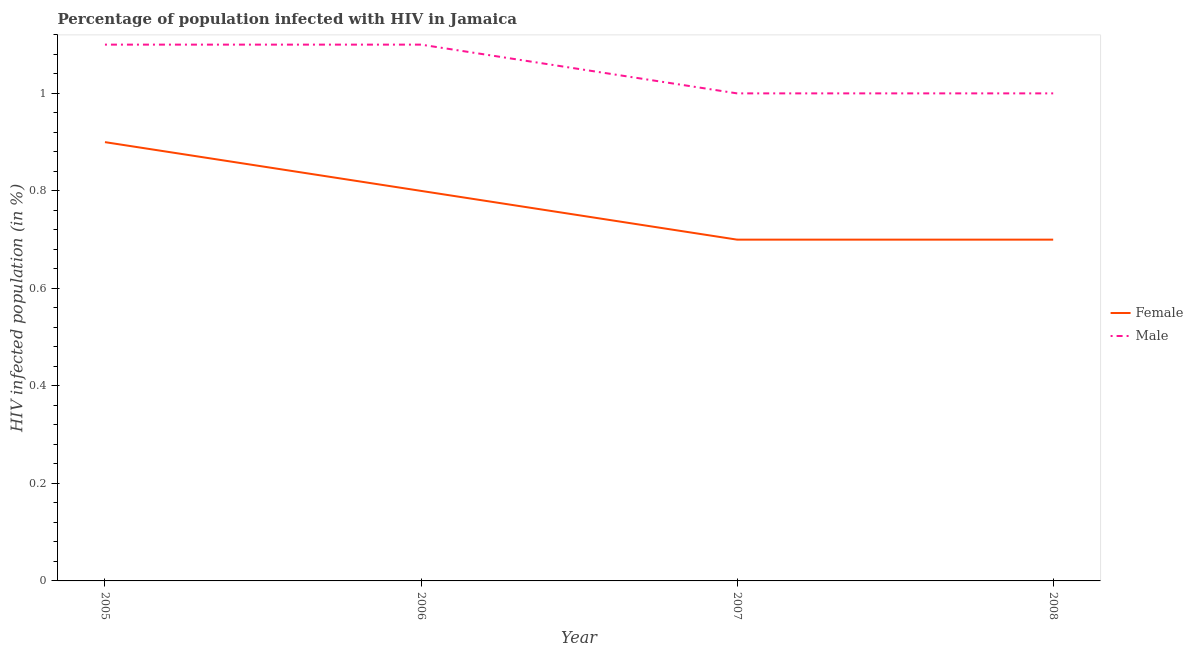How many different coloured lines are there?
Make the answer very short. 2. What is the total percentage of males who are infected with hiv in the graph?
Offer a very short reply. 4.2. What is the difference between the percentage of males who are infected with hiv in 2007 and the percentage of females who are infected with hiv in 2005?
Provide a succinct answer. 0.1. What is the average percentage of females who are infected with hiv per year?
Make the answer very short. 0.78. In the year 2006, what is the difference between the percentage of females who are infected with hiv and percentage of males who are infected with hiv?
Your answer should be compact. -0.3. In how many years, is the percentage of males who are infected with hiv greater than 0.48000000000000004 %?
Ensure brevity in your answer.  4. What is the ratio of the percentage of females who are infected with hiv in 2005 to that in 2006?
Provide a short and direct response. 1.12. Is the percentage of males who are infected with hiv in 2007 less than that in 2008?
Make the answer very short. No. Is the difference between the percentage of males who are infected with hiv in 2005 and 2006 greater than the difference between the percentage of females who are infected with hiv in 2005 and 2006?
Give a very brief answer. No. What is the difference between the highest and the second highest percentage of females who are infected with hiv?
Provide a succinct answer. 0.1. What is the difference between the highest and the lowest percentage of males who are infected with hiv?
Your answer should be very brief. 0.1. Is the percentage of females who are infected with hiv strictly greater than the percentage of males who are infected with hiv over the years?
Offer a terse response. No. How many lines are there?
Your response must be concise. 2. Are the values on the major ticks of Y-axis written in scientific E-notation?
Provide a succinct answer. No. Does the graph contain grids?
Provide a short and direct response. No. How are the legend labels stacked?
Ensure brevity in your answer.  Vertical. What is the title of the graph?
Ensure brevity in your answer.  Percentage of population infected with HIV in Jamaica. What is the label or title of the X-axis?
Offer a terse response. Year. What is the label or title of the Y-axis?
Your answer should be compact. HIV infected population (in %). What is the HIV infected population (in %) in Female in 2005?
Your answer should be very brief. 0.9. What is the HIV infected population (in %) of Male in 2005?
Your response must be concise. 1.1. What is the HIV infected population (in %) of Female in 2007?
Ensure brevity in your answer.  0.7. What is the HIV infected population (in %) in Female in 2008?
Ensure brevity in your answer.  0.7. Across all years, what is the maximum HIV infected population (in %) in Female?
Make the answer very short. 0.9. Across all years, what is the maximum HIV infected population (in %) of Male?
Give a very brief answer. 1.1. Across all years, what is the minimum HIV infected population (in %) of Female?
Keep it short and to the point. 0.7. Across all years, what is the minimum HIV infected population (in %) of Male?
Your response must be concise. 1. What is the difference between the HIV infected population (in %) of Female in 2005 and that in 2006?
Provide a succinct answer. 0.1. What is the difference between the HIV infected population (in %) in Male in 2005 and that in 2006?
Give a very brief answer. 0. What is the difference between the HIV infected population (in %) in Female in 2005 and that in 2007?
Keep it short and to the point. 0.2. What is the difference between the HIV infected population (in %) in Male in 2006 and that in 2007?
Provide a short and direct response. 0.1. What is the difference between the HIV infected population (in %) in Female in 2006 and that in 2008?
Offer a very short reply. 0.1. What is the difference between the HIV infected population (in %) of Male in 2006 and that in 2008?
Ensure brevity in your answer.  0.1. What is the difference between the HIV infected population (in %) of Female in 2005 and the HIV infected population (in %) of Male in 2006?
Provide a short and direct response. -0.2. What is the difference between the HIV infected population (in %) of Female in 2005 and the HIV infected population (in %) of Male in 2008?
Offer a terse response. -0.1. What is the difference between the HIV infected population (in %) of Female in 2006 and the HIV infected population (in %) of Male in 2008?
Provide a succinct answer. -0.2. What is the average HIV infected population (in %) in Female per year?
Your answer should be compact. 0.78. In the year 2007, what is the difference between the HIV infected population (in %) of Female and HIV infected population (in %) of Male?
Keep it short and to the point. -0.3. In the year 2008, what is the difference between the HIV infected population (in %) in Female and HIV infected population (in %) in Male?
Your response must be concise. -0.3. What is the ratio of the HIV infected population (in %) of Male in 2005 to that in 2006?
Your answer should be very brief. 1. What is the ratio of the HIV infected population (in %) in Female in 2005 to that in 2007?
Make the answer very short. 1.29. What is the ratio of the HIV infected population (in %) in Male in 2005 to that in 2007?
Offer a very short reply. 1.1. What is the ratio of the HIV infected population (in %) in Female in 2006 to that in 2008?
Provide a succinct answer. 1.14. What is the ratio of the HIV infected population (in %) in Male in 2006 to that in 2008?
Your answer should be compact. 1.1. What is the ratio of the HIV infected population (in %) of Female in 2007 to that in 2008?
Give a very brief answer. 1. What is the ratio of the HIV infected population (in %) in Male in 2007 to that in 2008?
Provide a short and direct response. 1. What is the difference between the highest and the second highest HIV infected population (in %) of Female?
Keep it short and to the point. 0.1. 